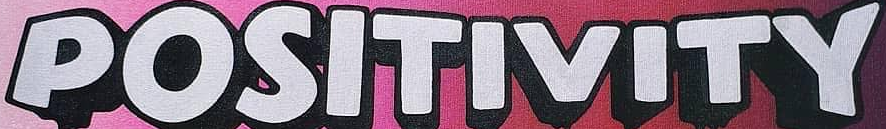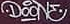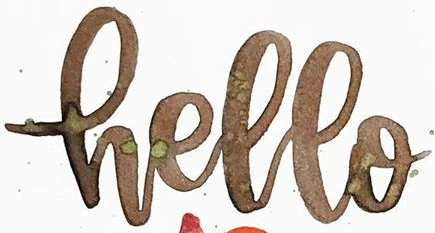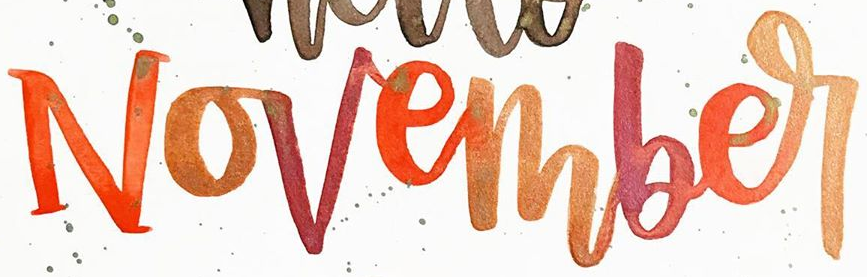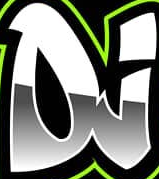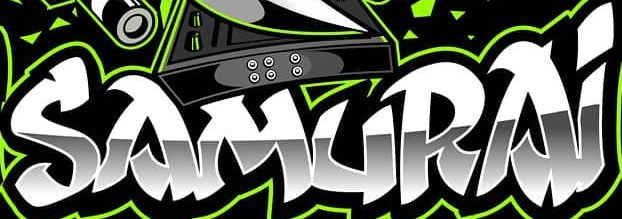What words are shown in these images in order, separated by a semicolon? POSITIVITY; DOONE; Hello; November; DJ; SAMURAi 